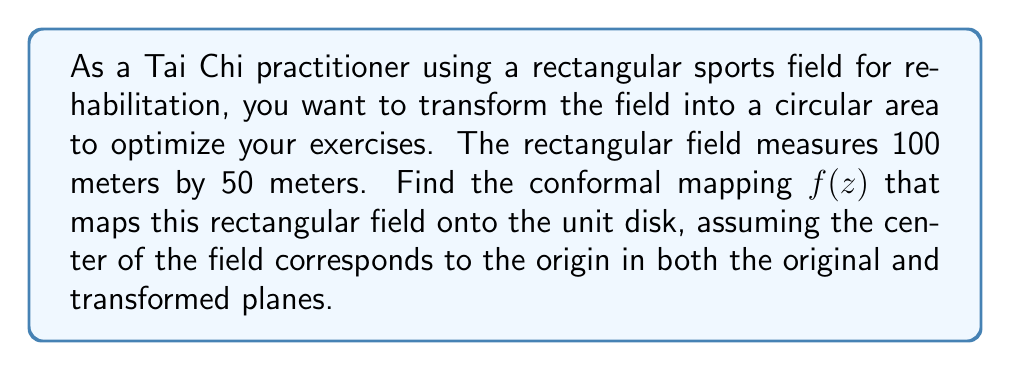Show me your answer to this math problem. To solve this problem, we'll follow these steps:

1) First, we need to normalize the rectangular field to fit the standard form for the Schwarz-Christoffel transformation. The field measures 100m by 50m, so we'll scale it to fit in the upper half-plane with corners at $\pm 1$ and $\pm k$ on the real axis, where $k > 1$.

2) The aspect ratio of the field is 2:1, so we can set up the equation:

   $\frac{K(k')}{K(k)} = \frac{1}{2}$

   where $K$ is the complete elliptic integral of the first kind, and $k' = \sqrt{1-k^2}$ is the complementary modulus.

3) This equation can be solved numerically to find $k \approx 1.18034$.

4) Now, we can use the Schwarz-Christoffel transformation to map the upper half-plane onto the unit disk:

   $w = \frac{z - i}{z + i}$

5) To map the rectangle to the upper half-plane, we use the Jacobi elliptic function:

   $z = k \cdot \text{sn}(u, k)$

   where $\text{sn}$ is the Jacobi elliptic sine function.

6) Composing these transformations, we get:

   $f(z) = \frac{k \cdot \text{sn}(\frac{2K(k)}{100}(x+iy), k) - i}{k \cdot \text{sn}(\frac{2K(k)}{100}(x+iy), k) + i}$

   where $x$ and $y$ are the coordinates on the original field, with the origin at the center.

7) This function $f(z)$ maps the rectangular field onto the unit disk, with the center of the field mapping to the origin of the disk.
Answer: The conformal mapping $f(z)$ from the rectangular sports field to the unit disk is:

$$f(z) = \frac{k \cdot \text{sn}(\frac{2K(k)}{100}(x+iy), k) - i}{k \cdot \text{sn}(\frac{2K(k)}{100}(x+iy), k) + i}$$

where $k \approx 1.18034$, $K(k)$ is the complete elliptic integral of the first kind, $\text{sn}$ is the Jacobi elliptic sine function, and $(x,y)$ are the coordinates on the original field with the origin at the center. 